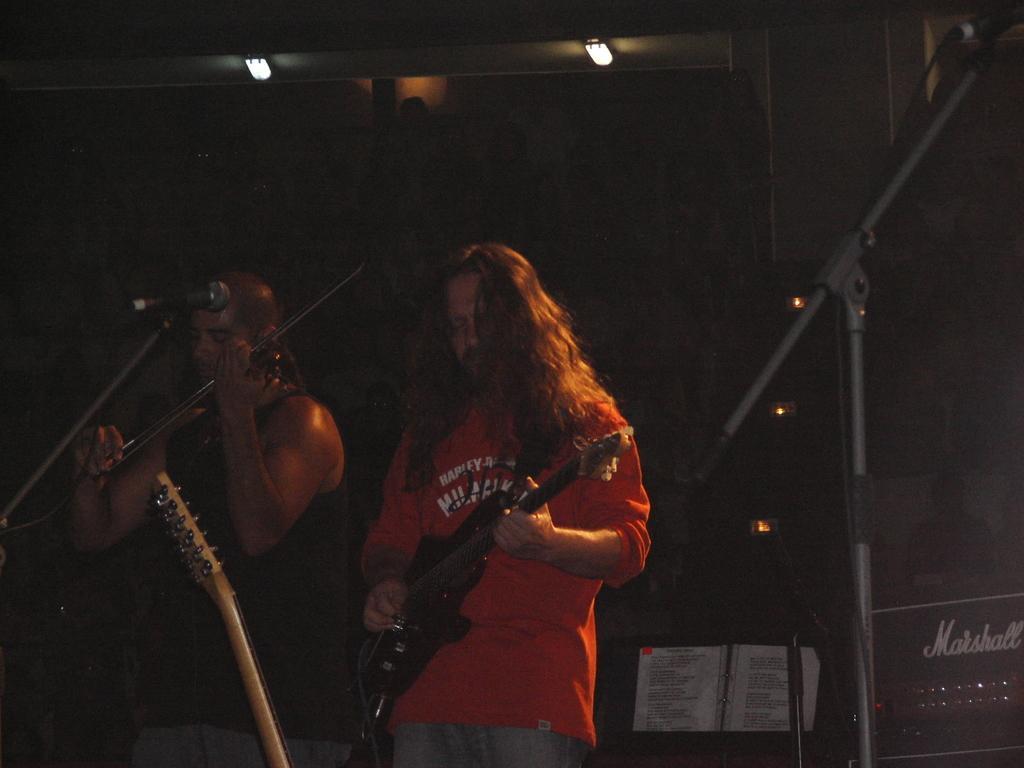Please provide a concise description of this image. In the image we can see two people standing and wearing clothes. This is a guitar, microphone and other musical instruments. There is a book, light and a stand. 